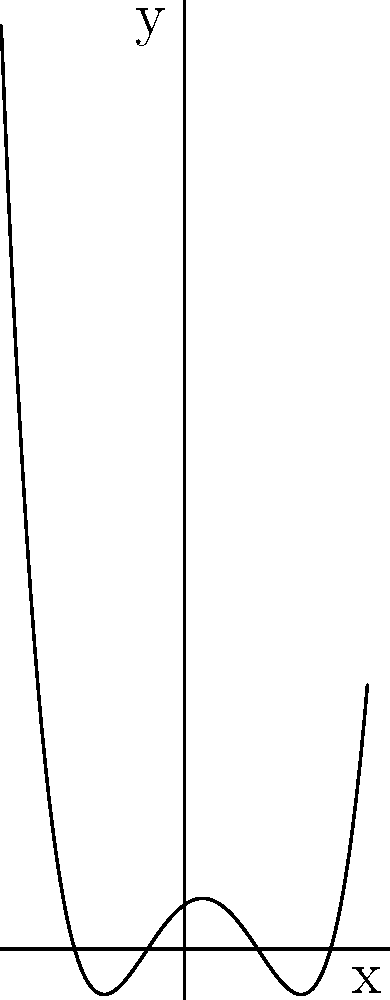As an educator exploring developer resources for teaching mathematics, you come across a tool for visualizing polynomial functions. Given a polynomial of degree 4, as shown in the graph above, determine the maximum number of turning points (local maxima and minima) this polynomial can have. How does this relate to the polynomial's degree? To answer this question, let's follow these steps:

1. Recall the relationship between a polynomial's degree and its turning points:
   - The maximum number of turning points for a polynomial of degree $n$ is $n-1$.

2. In this case, we're dealing with a polynomial of degree 4. So, let's apply the formula:
   $n = 4$
   Maximum number of turning points $= n - 1 = 4 - 1 = 3$

3. Let's verify this by looking at the graph:
   - We can see that the graph indeed has 3 turning points: 2 local minima and 1 local maximum.

4. The relationship between the degree and turning points:
   - For a polynomial of degree $n$, the maximum number of turning points is always $n-1$.
   - This is because the derivative of a polynomial of degree $n$ is a polynomial of degree $n-1$, and the turning points occur where the derivative equals zero.

5. In general:
   - Linear functions (degree 1) have no turning points.
   - Quadratic functions (degree 2) have at most 1 turning point.
   - Cubic functions (degree 3) have at most 2 turning points.
   - And so on...
Answer: 3 turning points; maximum turning points = degree - 1 